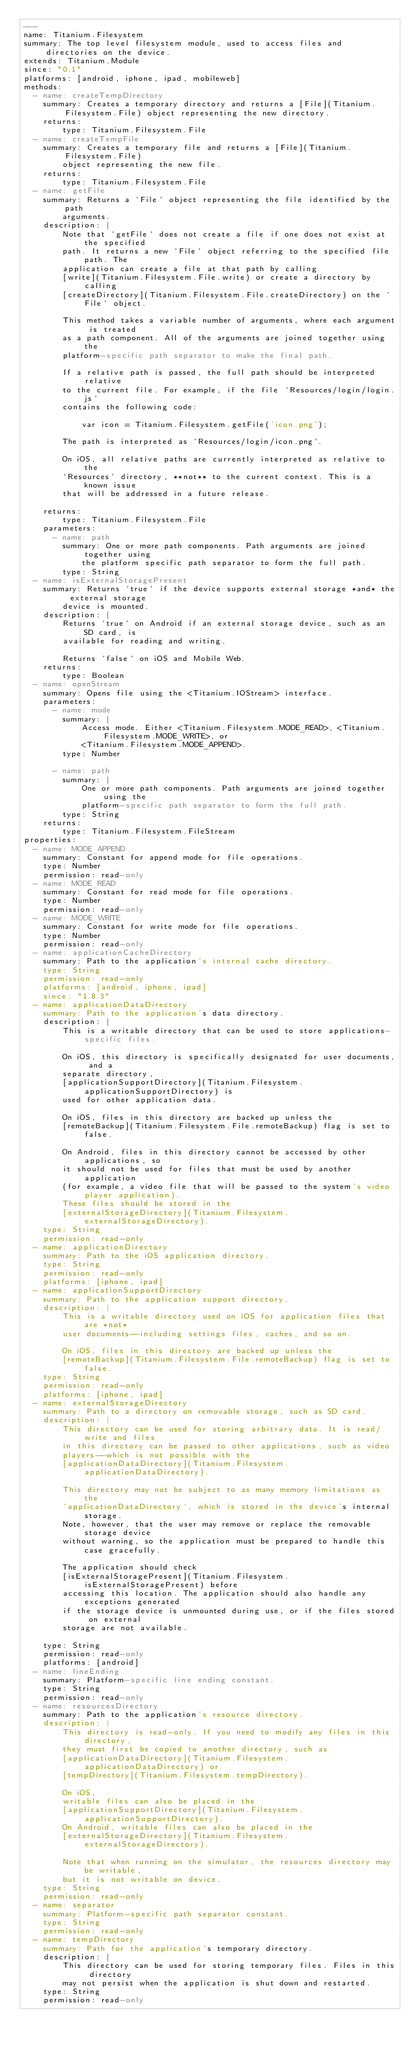Convert code to text. <code><loc_0><loc_0><loc_500><loc_500><_YAML_>---
name: Titanium.Filesystem
summary: The top level filesystem module, used to access files and directories on the device.
extends: Titanium.Module
since: "0.1"
platforms: [android, iphone, ipad, mobileweb]
methods:
  - name: createTempDirectory
    summary: Creates a temporary directory and returns a [File](Titanium.Filesystem.File) object representing the new directory.
    returns:
        type: Titanium.Filesystem.File
  - name: createTempFile
    summary: Creates a temporary file and returns a [File](Titanium.Filesystem.File)
        object representing the new file.
    returns:
        type: Titanium.Filesystem.File
  - name: getFile
    summary: Returns a `File` object representing the file identified by the path
        arguments.
    description: |
        Note that `getFile` does not create a file if one does not exist at the specified
        path. It returns a new `File` object referring to the specified file path. The 
        application can create a file at that path by calling 
        [write](Titanium.Filesystem.File.write) or create a directory by calling
        [createDirectory](Titanium.Filesystem.File.createDirectory) on the `File` object.
        
        This method takes a variable number of arguments, where each argument is treated
        as a path component. All of the arguments are joined together using the
        platform-specific path separator to make the final path.
        
        If a relative path is passed, the full path should be interpreted relative
        to the current file. For example, if the file `Resources/login/login.js` 
        contains the following code:
        
            var icon = Titanium.Filesystem.getFile('icon.png');
        
        The path is interpreted as `Resources/login/icon.png`. 
        
        On iOS, all relative paths are currently interpreted as relative to the
        `Resources` directory, **not** to the current context. This is a known issue
        that will be addressed in a future release.

    returns:
        type: Titanium.Filesystem.File
    parameters:
      - name: path
        summary: One or more path components. Path arguments are joined together using 
            the platform specific path separator to form the full path.
        type: String
  - name: isExternalStoragePresent
    summary: Returns `true` if the device supports external storage *and* the external storage
        device is mounted.
    description: |
        Returns `true` on Android if an external storage device, such as an SD card, is
        available for reading and writing.

        Returns `false` on iOS and Mobile Web.
    returns:
        type: Boolean
  - name: openStream
    summary: Opens file using the <Titanium.IOStream> interface.
    parameters:
      - name: mode
        summary: |
            Access mode. Either <Titanium.Filesystem.MODE_READ>, <Titanium.Filesystem.MODE_WRITE>, or 
            <Titanium.Filesystem.MODE_APPEND>.
        type: Number
        
      - name: path
        summary: |
            One or more path components. Path arguments are joined together using the 
            platform-specific path separator to form the full path. 
        type: String
    returns:
        type: Titanium.Filesystem.FileStream
properties:
  - name: MODE_APPEND
    summary: Constant for append mode for file operations.
    type: Number
    permission: read-only
  - name: MODE_READ
    summary: Constant for read mode for file operations.
    type: Number
    permission: read-only
  - name: MODE_WRITE
    summary: Constant for write mode for file operations.
    type: Number
    permission: read-only
  - name: applicationCacheDirectory
    summary: Path to the application's internal cache directory.
    type: String
    permission: read-only
    platforms: [android, iphone, ipad]
    since: "1.8.3"
  - name: applicationDataDirectory
    summary: Path to the application's data directory.
    description: |
        This is a writable directory that can be used to store applications-specific files. 

        On iOS, this directory is specifically designated for user documents, and a
        separate directory,
        [applicationSupportDirectory](Titanium.Filesystem.applicationSupportDirectory) is
        used for other application data.
        
        On iOS, files in this directory are backed up unless the
        [remoteBackup](Titanium.Filesystem.File.remoteBackup) flag is set to false.

        On Android, files in this directory cannot be accessed by other applications, so 
        it should not be used for files that must be used by another application 
        (for example, a video file that will be passed to the system's video player application).
        These files should be stored in the
        [externalStorageDirectory](Titanium.Filesystem.externalStorageDirectory).
    type: String
    permission: read-only
  - name: applicationDirectory
    summary: Path to the iOS application directory.
    type: String
    permission: read-only
    platforms: [iphone, ipad]
  - name: applicationSupportDirectory
    summary: Path to the application support directory.
    description: |
        This is a writable directory used on iOS for application files that are *not* 
        user documents--including settings files, caches, and so on.
        
        On iOS, files in this directory are backed up unless the
        [remoteBackup](Titanium.Filesystem.File.remoteBackup) flag is set to false.
    type: String
    permission: read-only
    platforms: [iphone, ipad]
  - name: externalStorageDirectory
    summary: Path to a directory on removable storage, such as SD card.
    description: |
        This directory can be used for storing arbitrary data. It is read/write and files
        in this directory can be passed to other applications, such as video
        players--which is not possible with the 
        [applicationDataDirectory](Titanium.Filesystem.applicationDataDirectory).

        This directory may not be subject to as many memory limitations as the
        `applicationDataDirectory`, which is stored in the device's internal storage.
        Note, however, that the user may remove or replace the removable storage device
        without warning, so the application must be prepared to handle this case gracefully. 
        
        The application should check
        [isExternalStoragePresent](Titanium.Filesystem.isExternalStoragePresent) before
        accessing this location. The application should also handle any exceptions generated 
        if the storage device is unmounted during use, or if the files stored on external 
        storage are not available.
        
    type: String
    permission: read-only
    platforms: [android]
  - name: lineEnding
    summary: Platform-specific line ending constant.
    type: String
    permission: read-only
  - name: resourcesDirectory
    summary: Path to the application's resource directory.
    description: |
        This directory is read-only. If you need to modify any files in this directory,
        they must first be copied to another directory, such as  
        [applicationDataDirectory](Titanium.Filesystem.applicationDataDirectory) or
        [tempDirectory](Titanium.Filesystem.tempDirectory). 
        
        On iOS, 
        writable files can also be placed in the 
        [applicationSupportDirectory](Titanium.Filesystem.applicationSupportDirectory).
        On Android, writable files can also be placed in the 
        [externalStorageDirectory](Titanium.Filesystem.externalStorageDirectory).

        Note that when running on the simulator, the resources directory may be writable,
        but it is not writable on device.
    type: String
    permission: read-only
  - name: separator
    summary: Platform-specific path separator constant.
    type: String
    permission: read-only
  - name: tempDirectory
    summary: Path for the application's temporary directory. 
    description: |
        This directory can be used for storing temporary files. Files in this directory
        may not persist when the application is shut down and restarted.
    type: String
    permission: read-only
</code> 